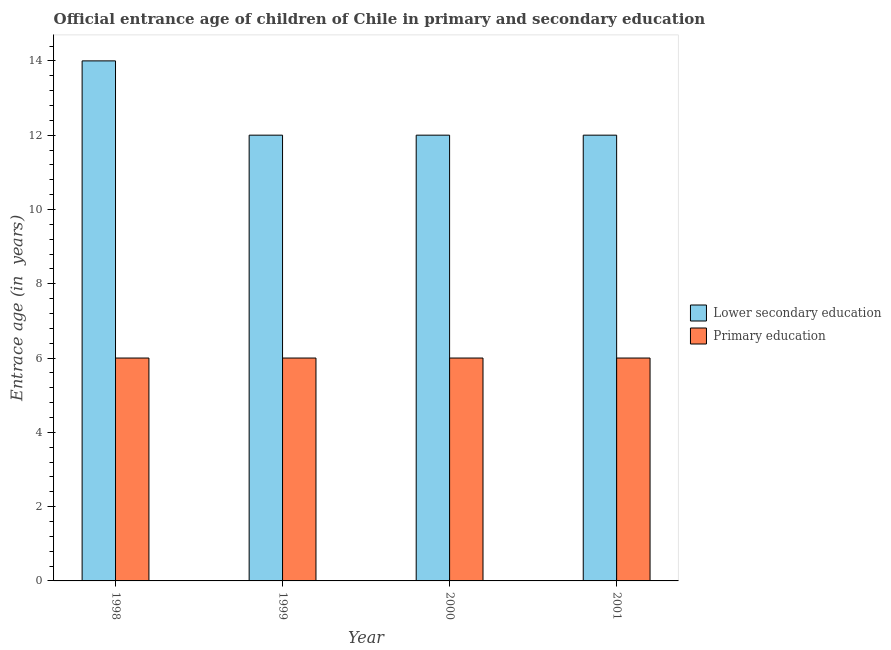How many groups of bars are there?
Your answer should be very brief. 4. How many bars are there on the 3rd tick from the left?
Your answer should be compact. 2. How many bars are there on the 1st tick from the right?
Provide a short and direct response. 2. What is the label of the 4th group of bars from the left?
Ensure brevity in your answer.  2001. What is the entrance age of children in lower secondary education in 1999?
Your answer should be very brief. 12. Across all years, what is the maximum entrance age of chiildren in primary education?
Give a very brief answer. 6. Across all years, what is the minimum entrance age of children in lower secondary education?
Keep it short and to the point. 12. In which year was the entrance age of chiildren in primary education maximum?
Offer a terse response. 1998. In which year was the entrance age of chiildren in primary education minimum?
Provide a short and direct response. 1998. What is the total entrance age of children in lower secondary education in the graph?
Your answer should be very brief. 50. What is the difference between the entrance age of chiildren in primary education in 1999 and that in 2000?
Make the answer very short. 0. In the year 1999, what is the difference between the entrance age of chiildren in primary education and entrance age of children in lower secondary education?
Your answer should be compact. 0. Is the entrance age of children in lower secondary education in 1998 less than that in 1999?
Give a very brief answer. No. What is the difference between the highest and the second highest entrance age of chiildren in primary education?
Your answer should be compact. 0. Is the sum of the entrance age of chiildren in primary education in 1999 and 2000 greater than the maximum entrance age of children in lower secondary education across all years?
Your answer should be very brief. Yes. What does the 2nd bar from the left in 2001 represents?
Provide a succinct answer. Primary education. Are all the bars in the graph horizontal?
Make the answer very short. No. Does the graph contain grids?
Your answer should be compact. No. Where does the legend appear in the graph?
Offer a very short reply. Center right. What is the title of the graph?
Offer a terse response. Official entrance age of children of Chile in primary and secondary education. Does "Frequency of shipment arrival" appear as one of the legend labels in the graph?
Make the answer very short. No. What is the label or title of the X-axis?
Provide a short and direct response. Year. What is the label or title of the Y-axis?
Give a very brief answer. Entrace age (in  years). What is the Entrace age (in  years) in Lower secondary education in 1998?
Make the answer very short. 14. What is the Entrace age (in  years) of Primary education in 1998?
Provide a short and direct response. 6. What is the Entrace age (in  years) of Primary education in 1999?
Your answer should be very brief. 6. What is the Entrace age (in  years) in Lower secondary education in 2000?
Your answer should be compact. 12. What is the Entrace age (in  years) of Primary education in 2000?
Give a very brief answer. 6. Across all years, what is the maximum Entrace age (in  years) in Lower secondary education?
Your answer should be compact. 14. Across all years, what is the maximum Entrace age (in  years) in Primary education?
Offer a terse response. 6. Across all years, what is the minimum Entrace age (in  years) of Primary education?
Your answer should be compact. 6. What is the total Entrace age (in  years) of Primary education in the graph?
Keep it short and to the point. 24. What is the difference between the Entrace age (in  years) of Lower secondary education in 1998 and that in 2000?
Give a very brief answer. 2. What is the difference between the Entrace age (in  years) of Lower secondary education in 1998 and that in 2001?
Your answer should be compact. 2. What is the difference between the Entrace age (in  years) of Primary education in 1999 and that in 2000?
Give a very brief answer. 0. What is the difference between the Entrace age (in  years) in Lower secondary education in 1999 and that in 2001?
Your answer should be very brief. 0. What is the difference between the Entrace age (in  years) of Primary education in 1999 and that in 2001?
Provide a succinct answer. 0. What is the difference between the Entrace age (in  years) in Lower secondary education in 2000 and that in 2001?
Your answer should be very brief. 0. What is the difference between the Entrace age (in  years) in Lower secondary education in 1998 and the Entrace age (in  years) in Primary education in 2000?
Give a very brief answer. 8. What is the difference between the Entrace age (in  years) of Lower secondary education in 1998 and the Entrace age (in  years) of Primary education in 2001?
Your response must be concise. 8. What is the difference between the Entrace age (in  years) in Lower secondary education in 1999 and the Entrace age (in  years) in Primary education in 2000?
Give a very brief answer. 6. What is the average Entrace age (in  years) of Primary education per year?
Your response must be concise. 6. In the year 1999, what is the difference between the Entrace age (in  years) of Lower secondary education and Entrace age (in  years) of Primary education?
Give a very brief answer. 6. In the year 2000, what is the difference between the Entrace age (in  years) of Lower secondary education and Entrace age (in  years) of Primary education?
Give a very brief answer. 6. In the year 2001, what is the difference between the Entrace age (in  years) in Lower secondary education and Entrace age (in  years) in Primary education?
Keep it short and to the point. 6. What is the ratio of the Entrace age (in  years) in Lower secondary education in 1998 to that in 1999?
Provide a short and direct response. 1.17. What is the ratio of the Entrace age (in  years) in Primary education in 1998 to that in 2000?
Keep it short and to the point. 1. What is the ratio of the Entrace age (in  years) in Primary education in 1998 to that in 2001?
Your answer should be very brief. 1. What is the ratio of the Entrace age (in  years) of Primary education in 1999 to that in 2000?
Offer a very short reply. 1. What is the ratio of the Entrace age (in  years) in Primary education in 1999 to that in 2001?
Provide a short and direct response. 1. What is the difference between the highest and the second highest Entrace age (in  years) in Lower secondary education?
Give a very brief answer. 2. What is the difference between the highest and the lowest Entrace age (in  years) of Primary education?
Ensure brevity in your answer.  0. 